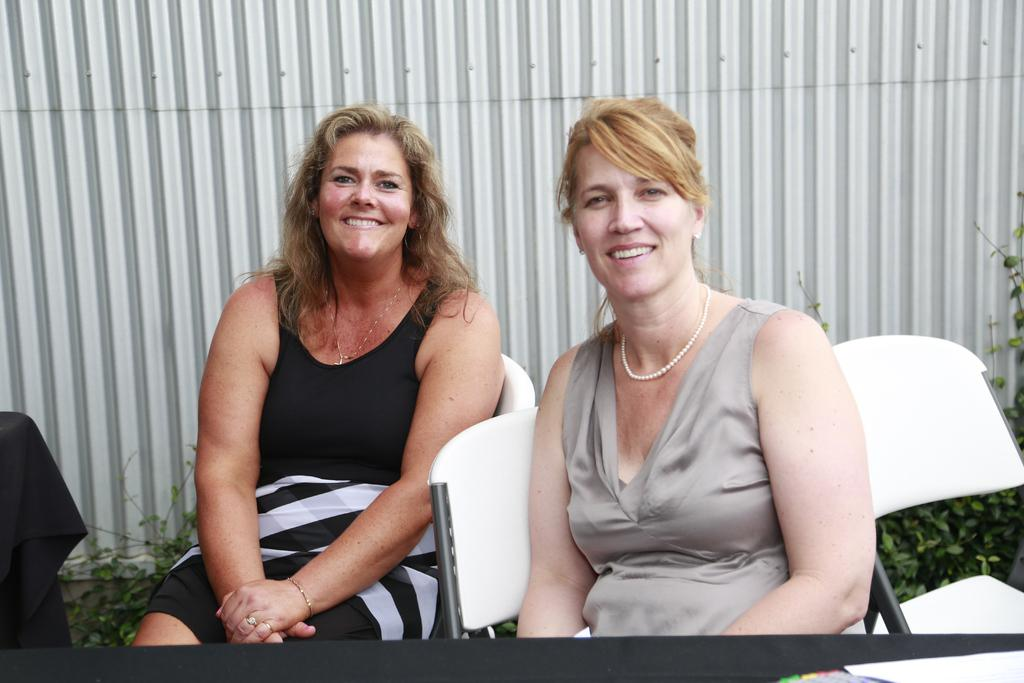How many people are in the image? There are two women in the image. What are the women doing in the image? The women are sitting on chairs and smiling. What can be seen in the image besides the women? There are plants, cloth, and a wall visible in the image. What type of sweater is the woman on the left wearing in the image? There is no sweater visible in the image; the women are not wearing any clothing items mentioned. 